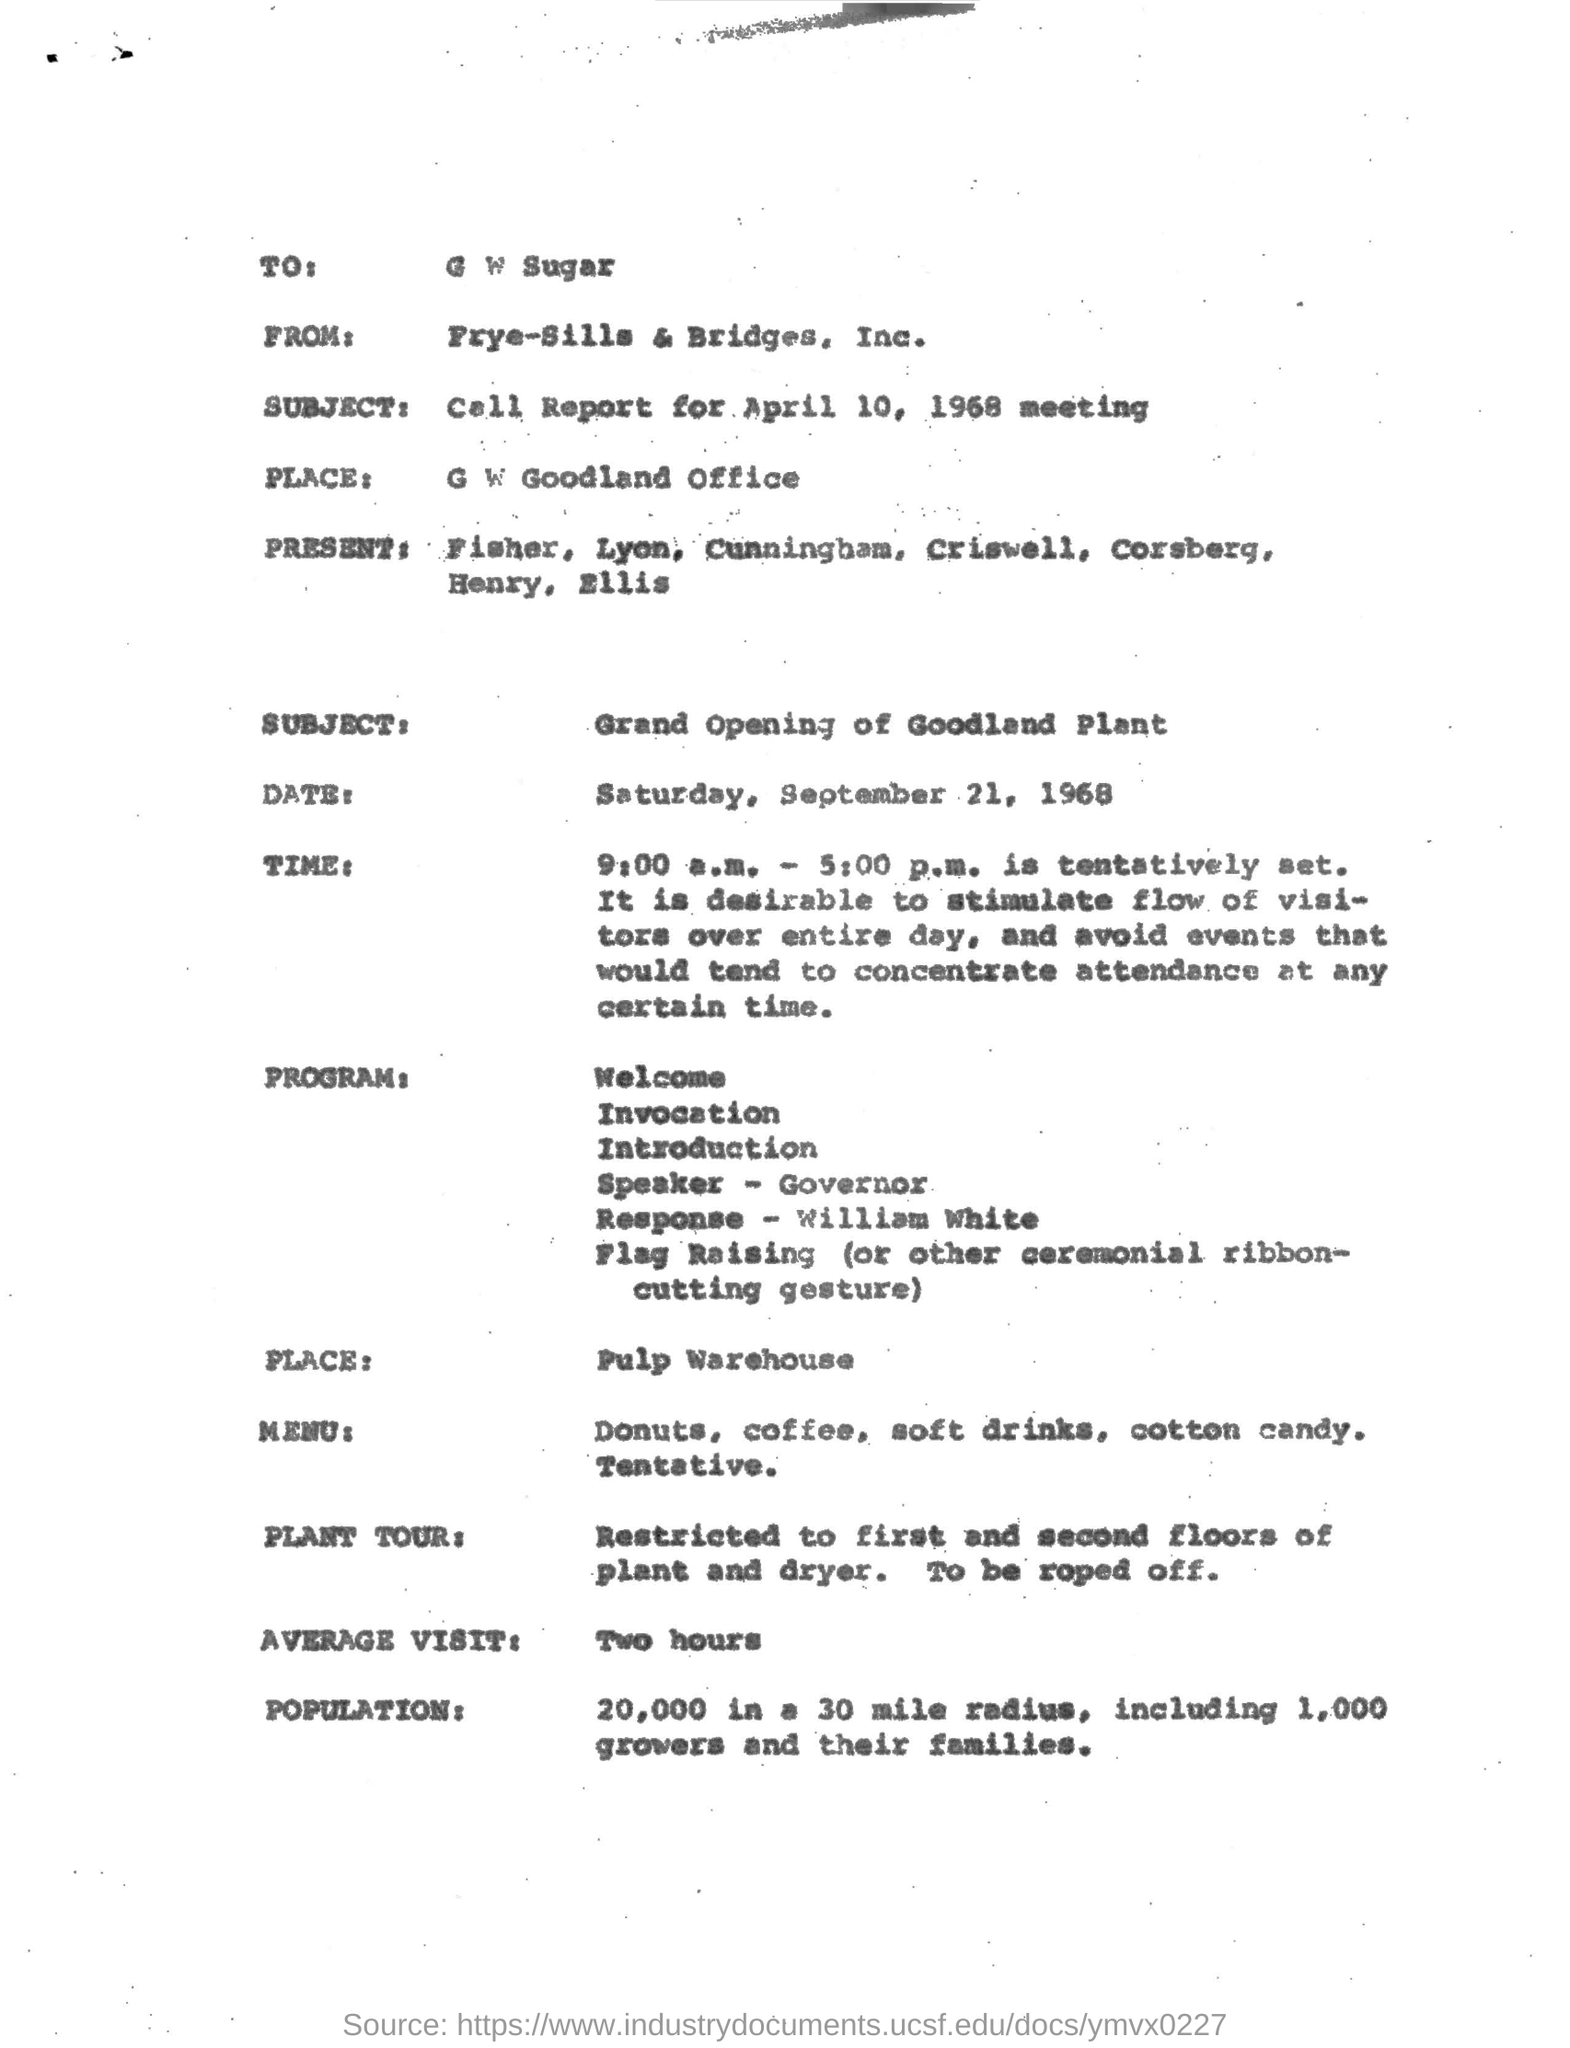Identify some key points in this picture. The average visit lasts approximately two hours. The letter is addressed to "G W SUGAR". 